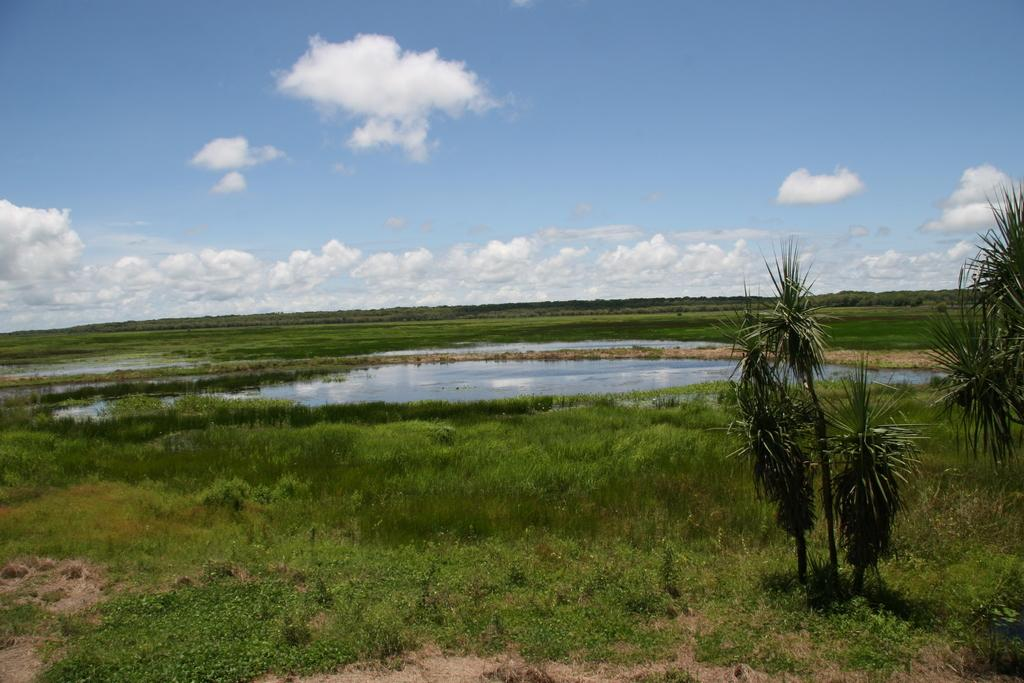What type of vegetation can be seen in the image? There are trees in the image. What is on the ground in the image? There is grass on the ground in the image. What can be seen in the water in the image? The facts do not specify what can be seen in the water. What is visible in the background of the image? The sky is visible in the background of the image. What can be observed in the sky? Clouds are present in the sky. What is the price of the trees in the image? The facts do not provide any information about the price of the trees, as they are natural elements and not for sale. What is the value of the clouds in the image? The facts do not provide any information about the value of the clouds, as they are natural elements and not for sale. 